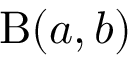Convert formula to latex. <formula><loc_0><loc_0><loc_500><loc_500>\mathrm { B } ( a , b )</formula> 